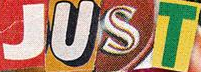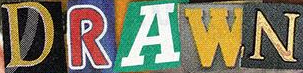What words are shown in these images in order, separated by a semicolon? JUST; DRAWN 